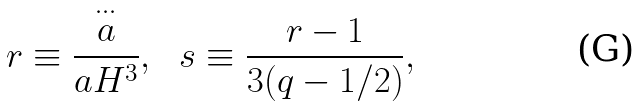Convert formula to latex. <formula><loc_0><loc_0><loc_500><loc_500>r \equiv \frac { \stackrel { \cdots } { a } } { a H ^ { 3 } } , \ \ s \equiv \frac { r - 1 } { 3 ( q - 1 / 2 ) } ,</formula> 